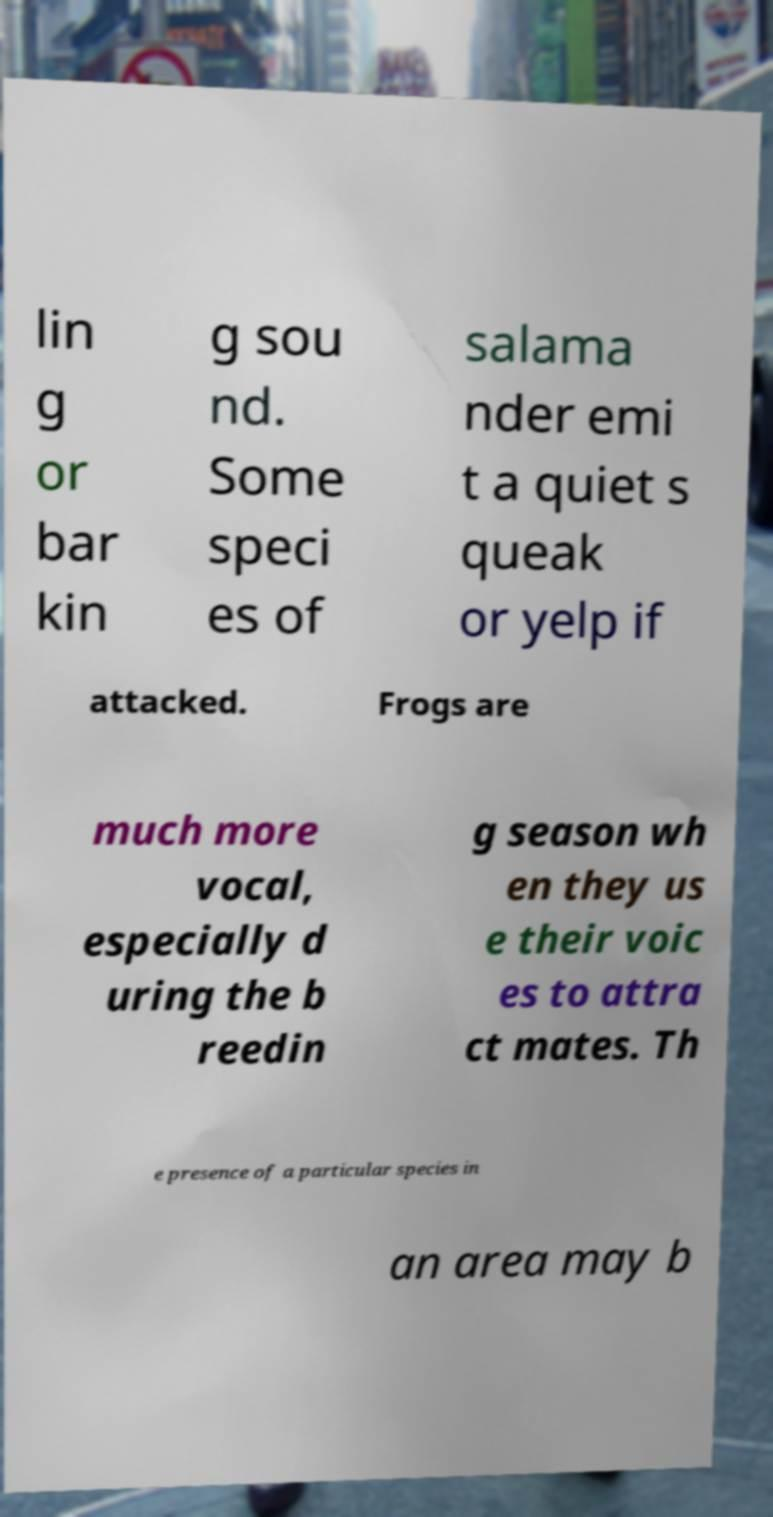There's text embedded in this image that I need extracted. Can you transcribe it verbatim? lin g or bar kin g sou nd. Some speci es of salama nder emi t a quiet s queak or yelp if attacked. Frogs are much more vocal, especially d uring the b reedin g season wh en they us e their voic es to attra ct mates. Th e presence of a particular species in an area may b 